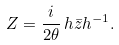<formula> <loc_0><loc_0><loc_500><loc_500>Z = \frac { i } { 2 \theta } \, h \bar { z } h ^ { - 1 } .</formula> 